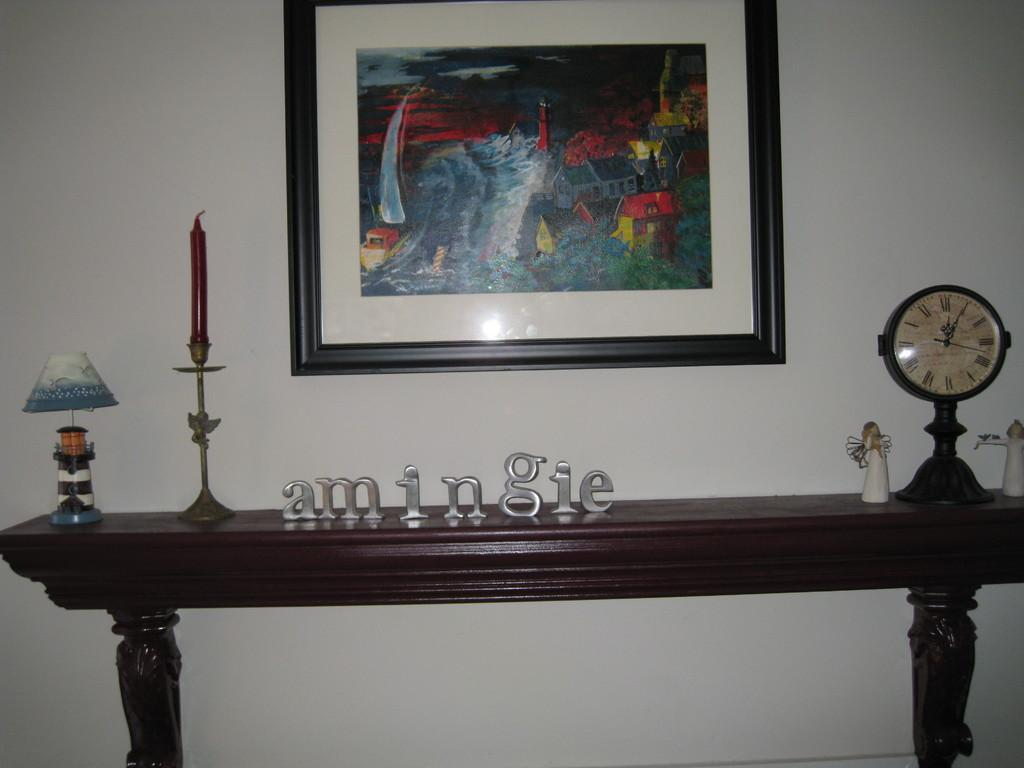<image>
Give a short and clear explanation of the subsequent image. Brown wooden table that has the word "Amingie" on top. 